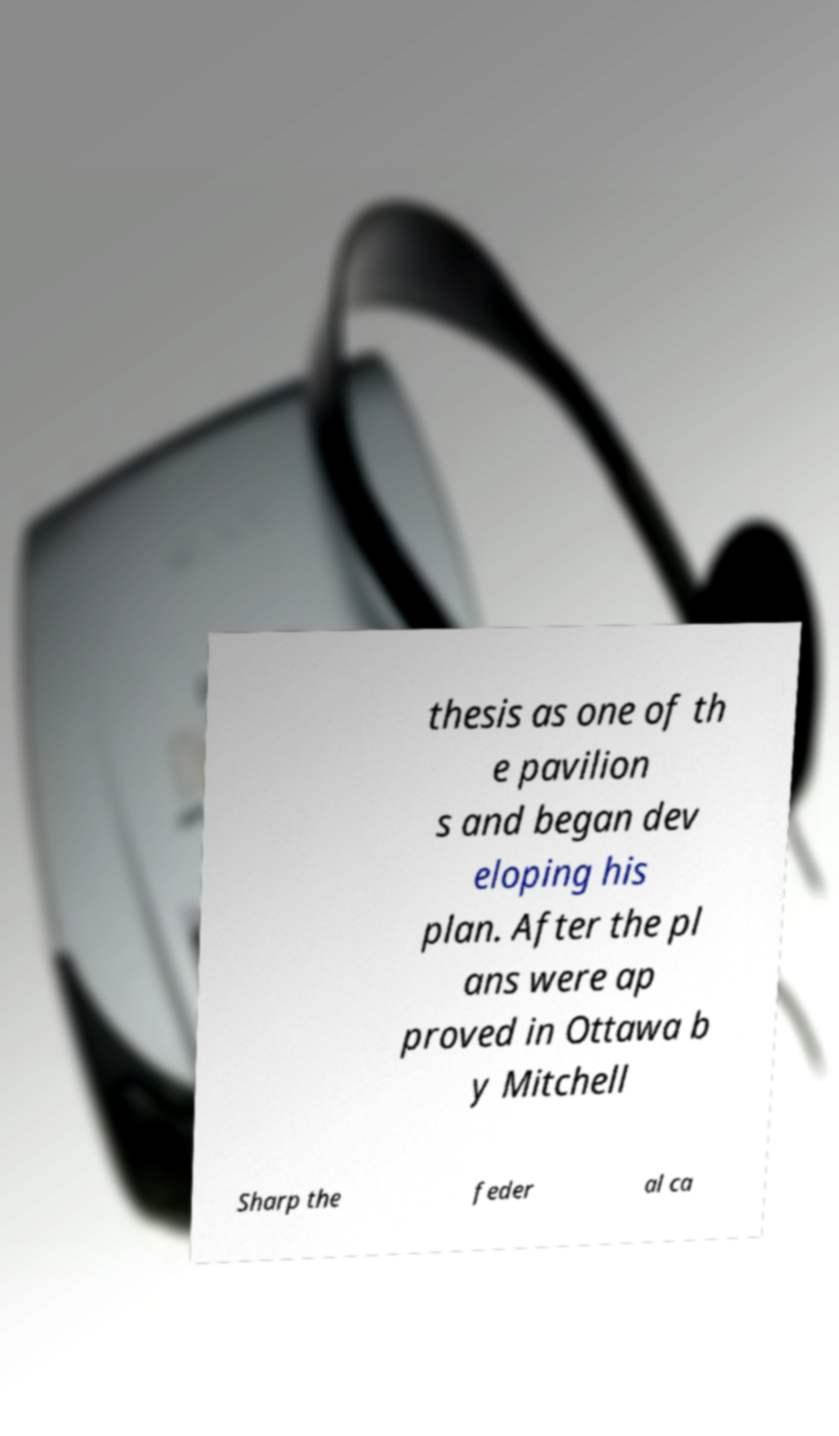For documentation purposes, I need the text within this image transcribed. Could you provide that? thesis as one of th e pavilion s and began dev eloping his plan. After the pl ans were ap proved in Ottawa b y Mitchell Sharp the feder al ca 